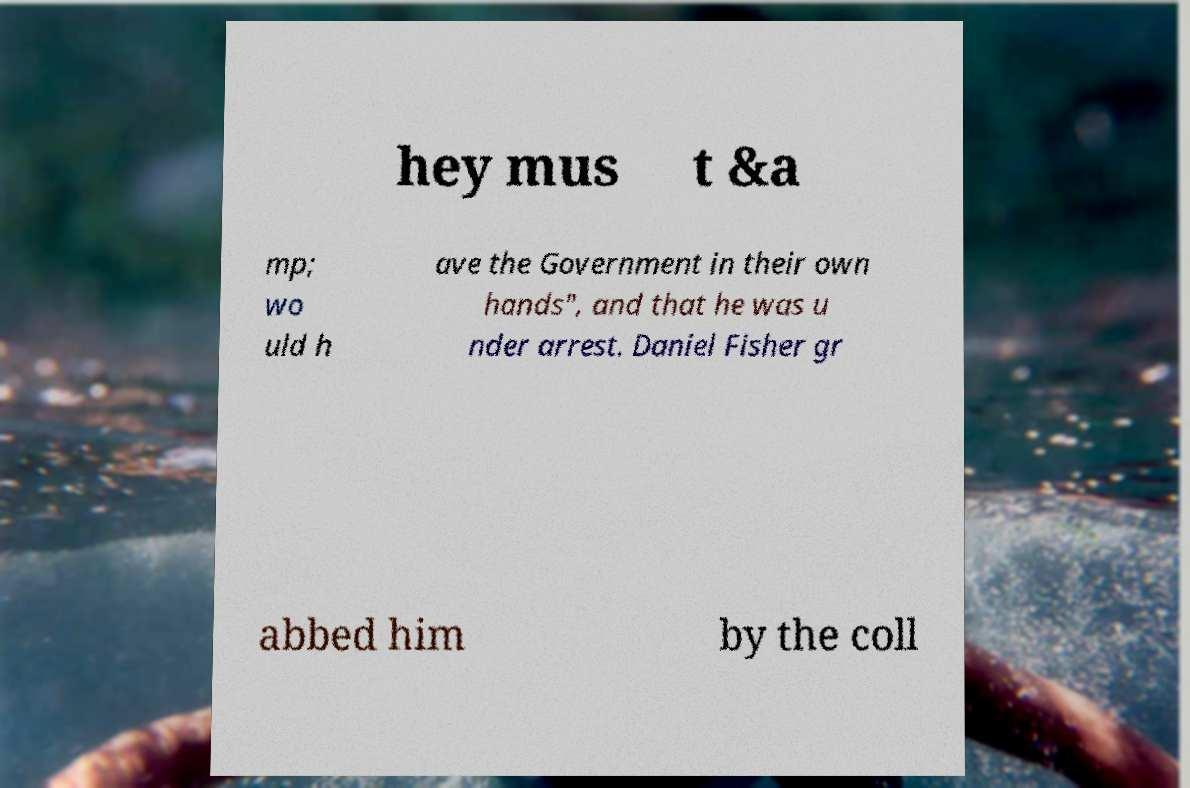Could you assist in decoding the text presented in this image and type it out clearly? hey mus t &a mp; wo uld h ave the Government in their own hands", and that he was u nder arrest. Daniel Fisher gr abbed him by the coll 